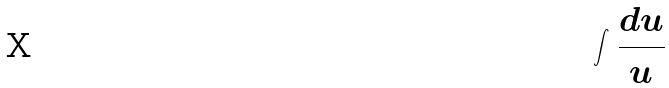<formula> <loc_0><loc_0><loc_500><loc_500>\int \frac { d u } { u }</formula> 